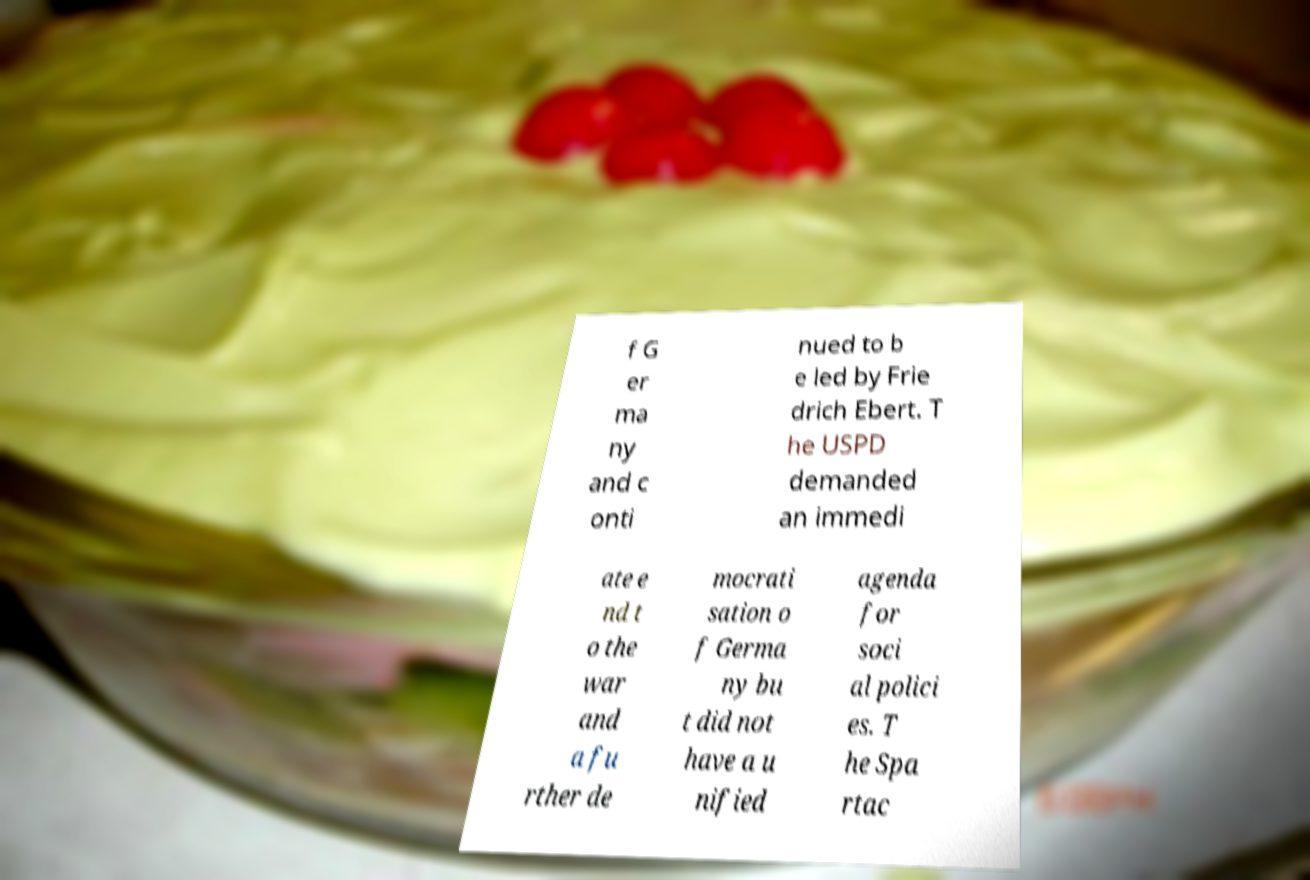Please read and relay the text visible in this image. What does it say? f G er ma ny and c onti nued to b e led by Frie drich Ebert. T he USPD demanded an immedi ate e nd t o the war and a fu rther de mocrati sation o f Germa ny bu t did not have a u nified agenda for soci al polici es. T he Spa rtac 